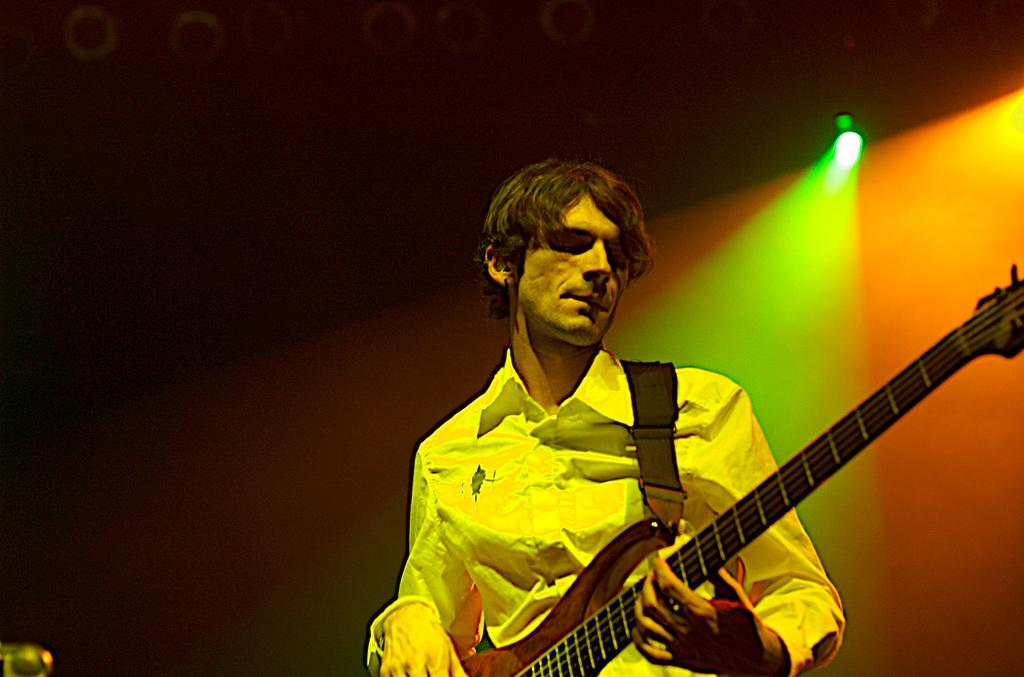Who is present in the image? There is a man in the image. What is the man doing in the image? The man is standing in the image. What object is the man holding in the image? The man is holding a guitar in the image. What can be seen in the background of the image? There is a light in the background of the image. What type of school can be seen in the image? There is no school present in the image. How does the man rest his guitar in the image? The man is holding the guitar, so it is not resting in the image. 